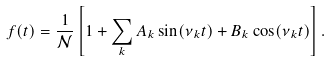<formula> <loc_0><loc_0><loc_500><loc_500>f ( t ) = \frac { 1 } { \mathcal { N } } \left [ 1 + \sum _ { k } A _ { k } \sin ( \nu _ { k } t ) + B _ { k } \cos ( \nu _ { k } t ) \right ] .</formula> 